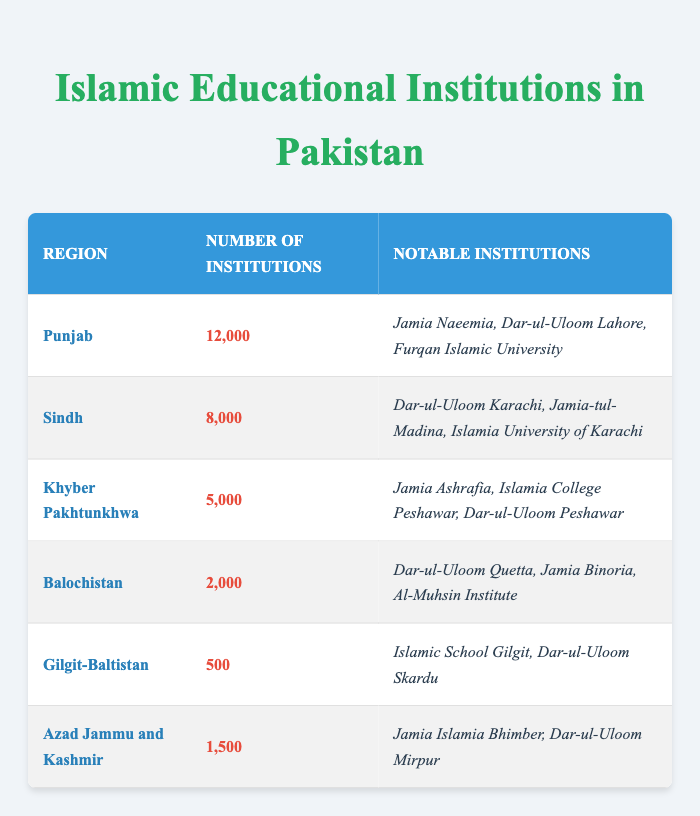What is the total number of Islamic educational institutions in Pakistan? To find the total number of institutions, I will sum up the values from all regions: 12000 (Punjab) + 8000 (Sindh) + 5000 (Khyber Pakhtunkhwa) + 2000 (Balochistan) + 500 (Gilgit-Baltistan) + 1500 (Azad Jammu and Kashmir) = 30000.
Answer: 30000 Which region has the highest number of Islamic educational institutions? By comparing the numbers in each region, Punjab has 12000 institutions, which is greater than the numbers in other regions.
Answer: Punjab How many notable institutions are listed for Sindh? The number of notable institutions for Sindh listed in the table is three: Dar-ul-Uloom Karachi, Jamia-tul-Madina, and Islamia University of Karachi.
Answer: 3 Is there a region with fewer than 1000 Islamic educational institutions? When observing the data, Gilgit-Baltistan has only 500 institutions, which is less than 1000.
Answer: Yes What is the difference in the number of institutions between Punjab and Balochistan? The difference can be calculated as: 12000 (Punjab) - 2000 (Balochistan) = 10000.
Answer: 10000 Which region has the least number of Islamic educational institutions? By reviewing the numbers, Gilgit-Baltistan has the least, with only 500 institutions.
Answer: Gilgit-Baltistan What is the average number of institutions across all regions? To calculate the average, I sum the institutions (30000) and divide by the number of regions (6): 30000 / 6 = 5000.
Answer: 5000 Are there any notable institutions mentioned for Balochistan? Yes, the notable institutions listed for Balochistan are Dar-ul-Uloom Quetta, Jamia Binoria, and Al-Muhsin Institute.
Answer: Yes How many more institutions does Sindh have compared to Khyber Pakhtunkhwa? The difference is calculated as: 8000 (Sindh) - 5000 (Khyber Pakhtunkhwa) = 3000.
Answer: 3000 List the notable institutions for Azad Jammu and Kashmir. The notable institutions for Azad Jammu and Kashmir are Jamia Islamia Bhimber and Dar-ul-Uloom Mirpur.
Answer: Jamia Islamia Bhimber, Dar-ul-Uloom Mirpur 